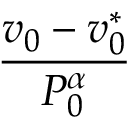<formula> <loc_0><loc_0><loc_500><loc_500>\frac { v _ { 0 } - v _ { 0 } ^ { * } } { P _ { 0 } ^ { \alpha } }</formula> 